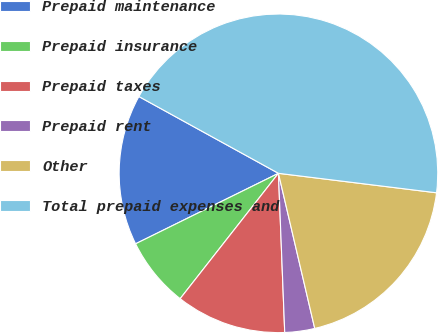Convert chart. <chart><loc_0><loc_0><loc_500><loc_500><pie_chart><fcel>Prepaid maintenance<fcel>Prepaid insurance<fcel>Prepaid taxes<fcel>Prepaid rent<fcel>Other<fcel>Total prepaid expenses and<nl><fcel>15.3%<fcel>7.12%<fcel>11.21%<fcel>3.03%<fcel>19.39%<fcel>43.94%<nl></chart> 